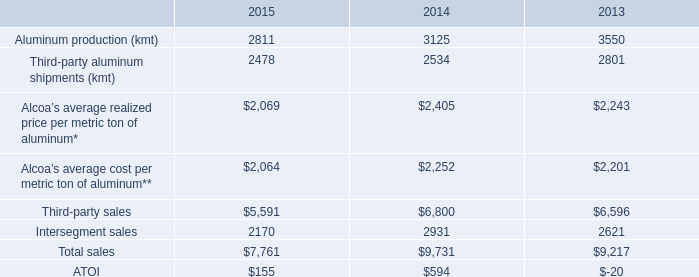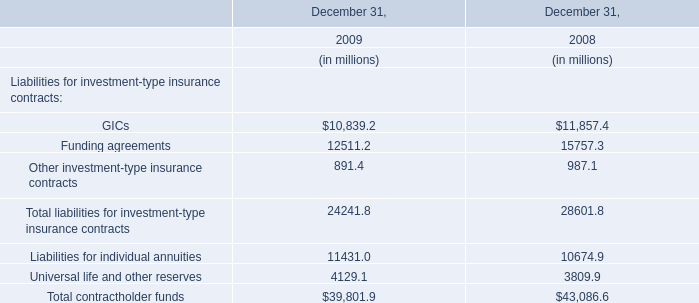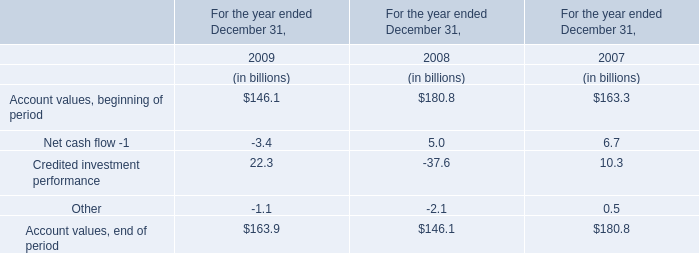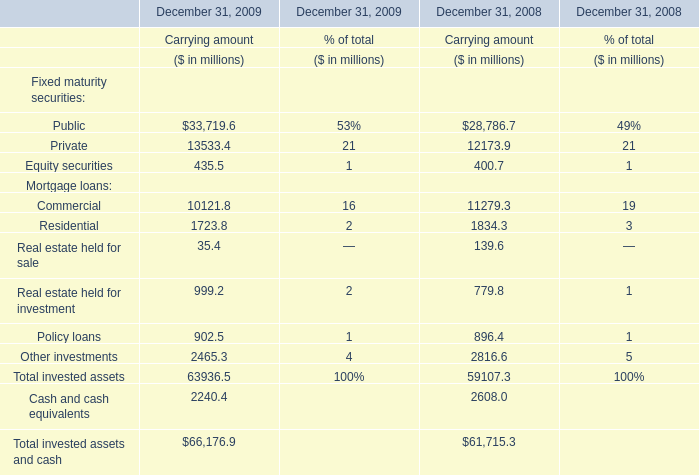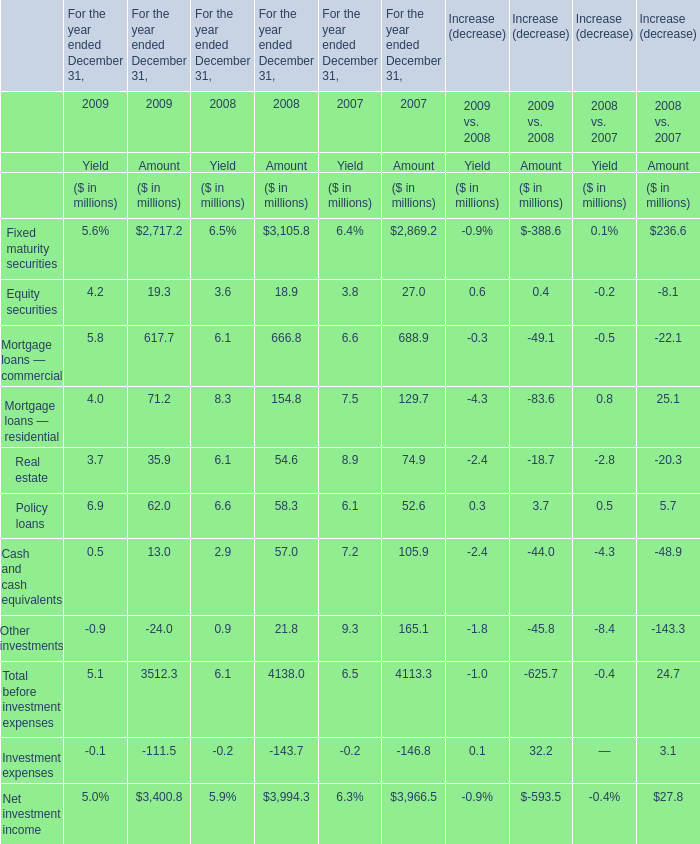How many kinds of Fixed maturity securities are greater than 10000 in 2009 
Answer: 2 (public and private). 